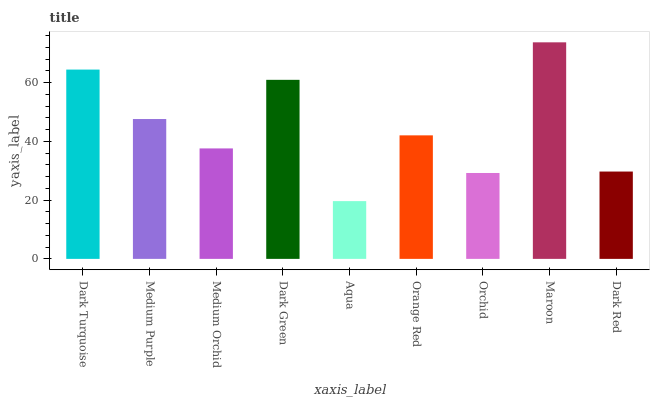Is Medium Purple the minimum?
Answer yes or no. No. Is Medium Purple the maximum?
Answer yes or no. No. Is Dark Turquoise greater than Medium Purple?
Answer yes or no. Yes. Is Medium Purple less than Dark Turquoise?
Answer yes or no. Yes. Is Medium Purple greater than Dark Turquoise?
Answer yes or no. No. Is Dark Turquoise less than Medium Purple?
Answer yes or no. No. Is Orange Red the high median?
Answer yes or no. Yes. Is Orange Red the low median?
Answer yes or no. Yes. Is Dark Turquoise the high median?
Answer yes or no. No. Is Dark Green the low median?
Answer yes or no. No. 